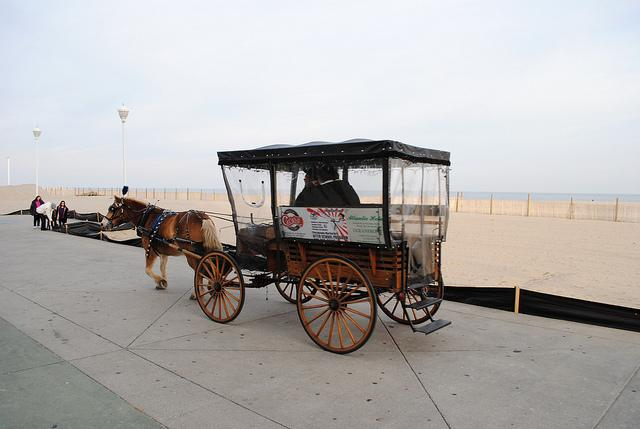What is near the sidewalk here? beach 